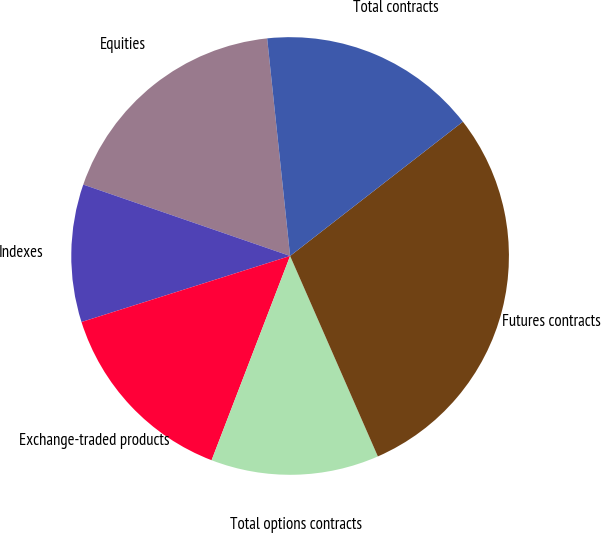Convert chart to OTSL. <chart><loc_0><loc_0><loc_500><loc_500><pie_chart><fcel>Equities<fcel>Indexes<fcel>Exchange-traded products<fcel>Total options contracts<fcel>Futures contracts<fcel>Total contracts<nl><fcel>18.04%<fcel>10.17%<fcel>14.28%<fcel>12.41%<fcel>28.95%<fcel>16.16%<nl></chart> 